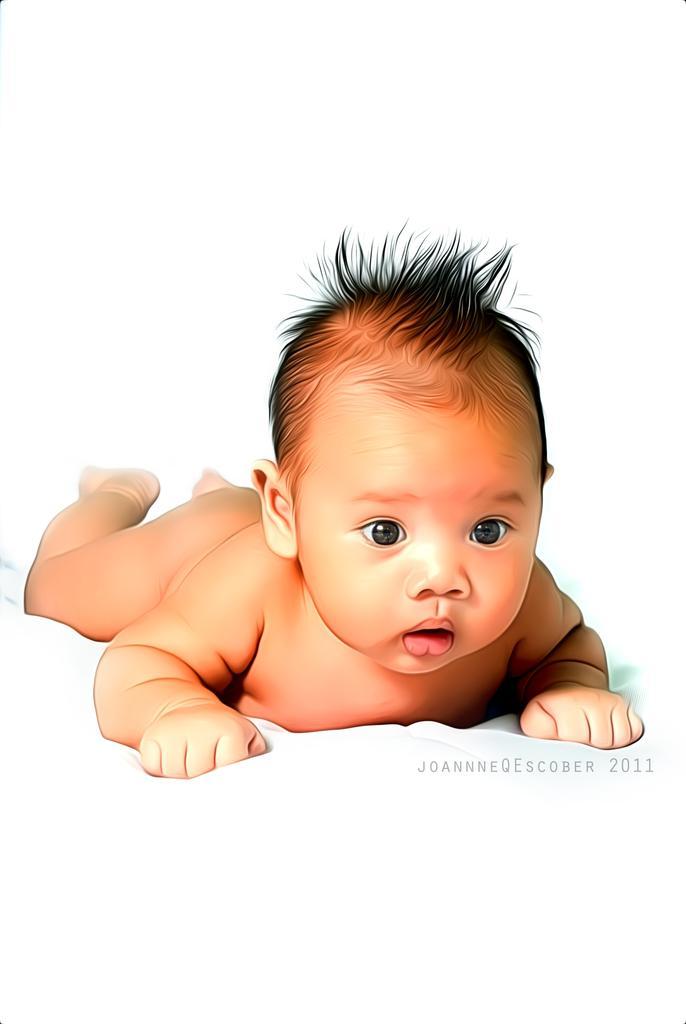Can you describe this image briefly? In the image I can see a small kid who is laying on the floor. 